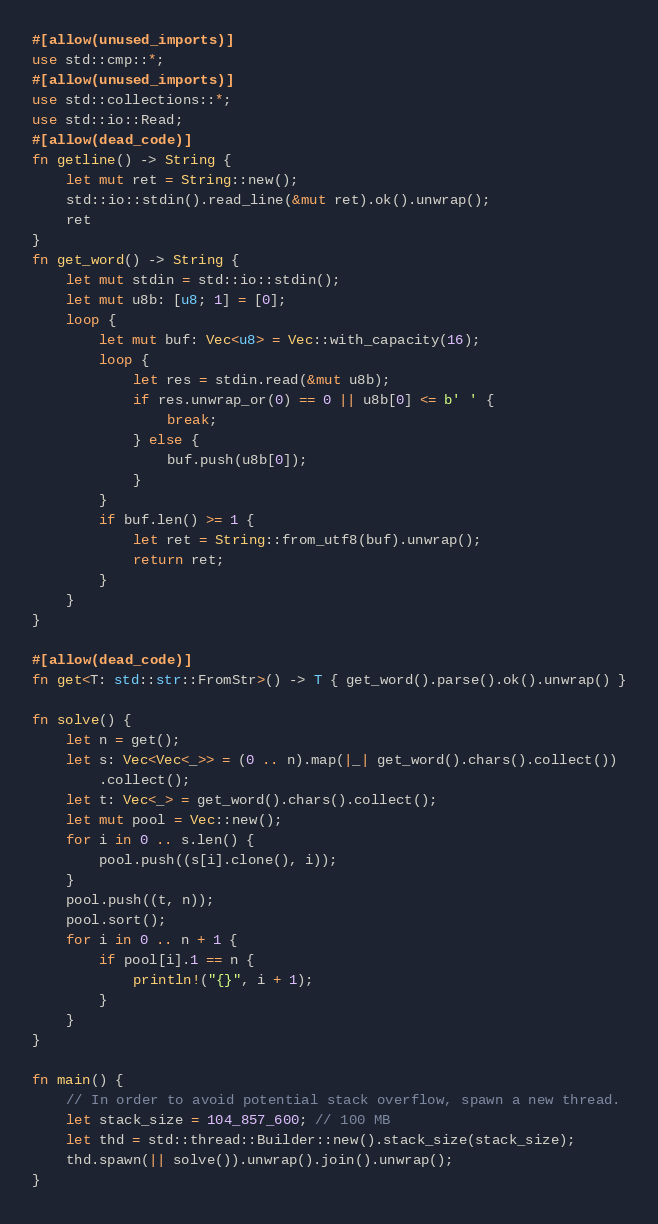Convert code to text. <code><loc_0><loc_0><loc_500><loc_500><_Rust_>#[allow(unused_imports)]
use std::cmp::*;
#[allow(unused_imports)]
use std::collections::*;
use std::io::Read;
#[allow(dead_code)]
fn getline() -> String {
    let mut ret = String::new();
    std::io::stdin().read_line(&mut ret).ok().unwrap();
    ret
}
fn get_word() -> String {
    let mut stdin = std::io::stdin();
    let mut u8b: [u8; 1] = [0];
    loop {
        let mut buf: Vec<u8> = Vec::with_capacity(16);
        loop {
            let res = stdin.read(&mut u8b);
            if res.unwrap_or(0) == 0 || u8b[0] <= b' ' {
                break;
            } else {
                buf.push(u8b[0]);
            }
        }
        if buf.len() >= 1 {
            let ret = String::from_utf8(buf).unwrap();
            return ret;
        }
    }
}

#[allow(dead_code)]
fn get<T: std::str::FromStr>() -> T { get_word().parse().ok().unwrap() }

fn solve() {
    let n = get();
    let s: Vec<Vec<_>> = (0 .. n).map(|_| get_word().chars().collect())
        .collect();
    let t: Vec<_> = get_word().chars().collect();
    let mut pool = Vec::new();
    for i in 0 .. s.len() {
        pool.push((s[i].clone(), i));
    }
    pool.push((t, n));
    pool.sort();
    for i in 0 .. n + 1 {
        if pool[i].1 == n {
            println!("{}", i + 1);
        }
    }
}

fn main() {
    // In order to avoid potential stack overflow, spawn a new thread.
    let stack_size = 104_857_600; // 100 MB
    let thd = std::thread::Builder::new().stack_size(stack_size);
    thd.spawn(|| solve()).unwrap().join().unwrap();
}
</code> 